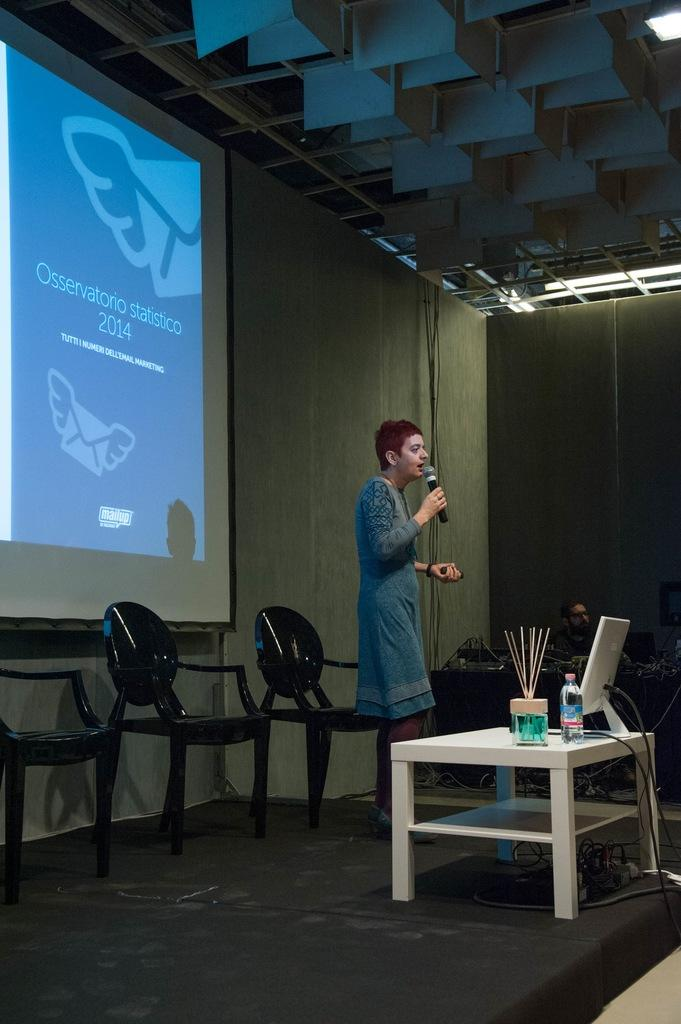Provide a one-sentence caption for the provided image. A woman gives a speech under a large screen with the headline Osservatorio statistico 2014. 